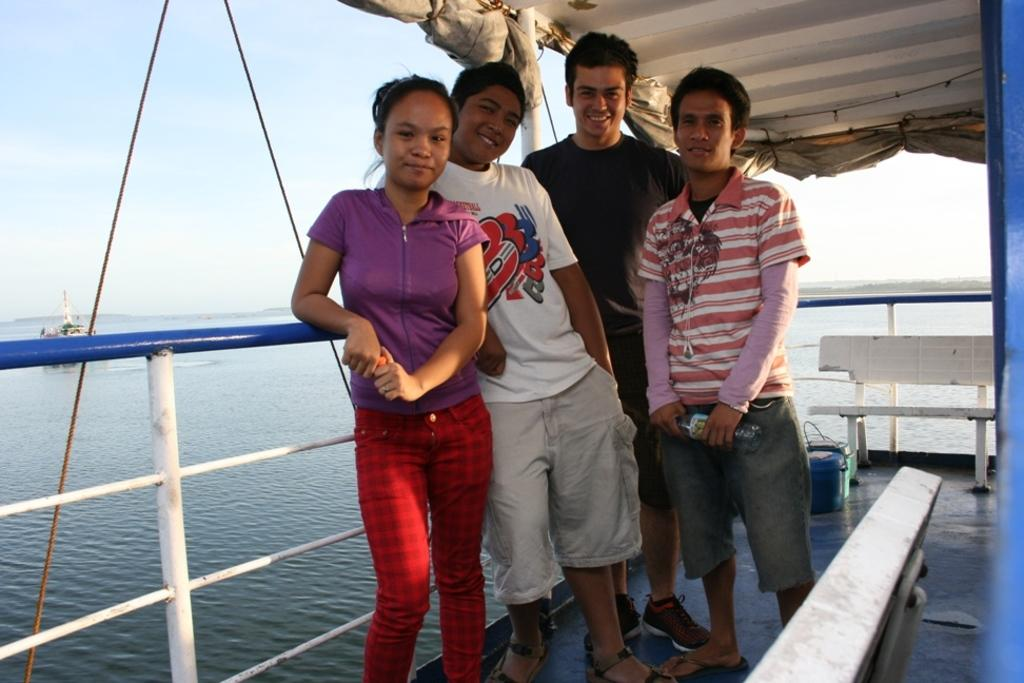How many people are in the image? There are four people in the image. What can be observed about the people's clothing? The people are wearing different color dresses. Where are the people located in the image? The people are inside a ship. What can be seen in the background of the image? There is water visible in the image. What other type of watercraft is present in the image? There is a boat in the image. What is the color of the sky in the image? The sky is blue and white in color. Can you see the tail of the fish in the image? There is no fish or tail present in the image. Are the people in the image kissing each other? The image does not show any kissing between the people. 